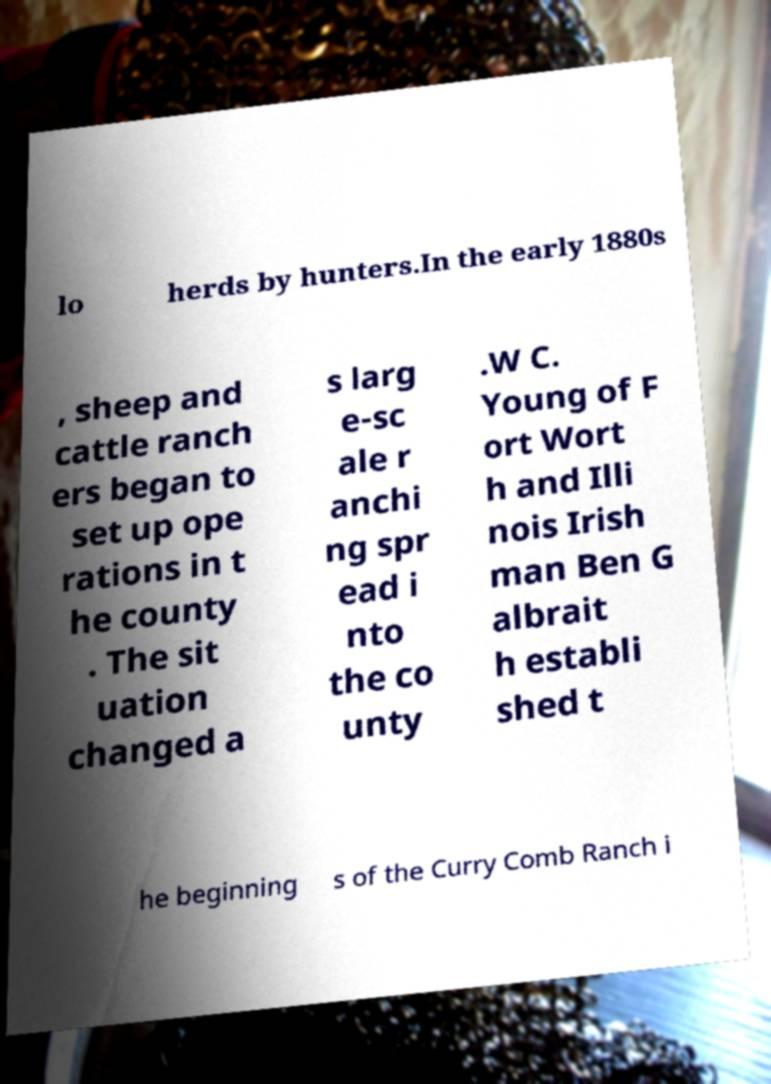Can you accurately transcribe the text from the provided image for me? lo herds by hunters.In the early 1880s , sheep and cattle ranch ers began to set up ope rations in t he county . The sit uation changed a s larg e-sc ale r anchi ng spr ead i nto the co unty .W C. Young of F ort Wort h and Illi nois Irish man Ben G albrait h establi shed t he beginning s of the Curry Comb Ranch i 